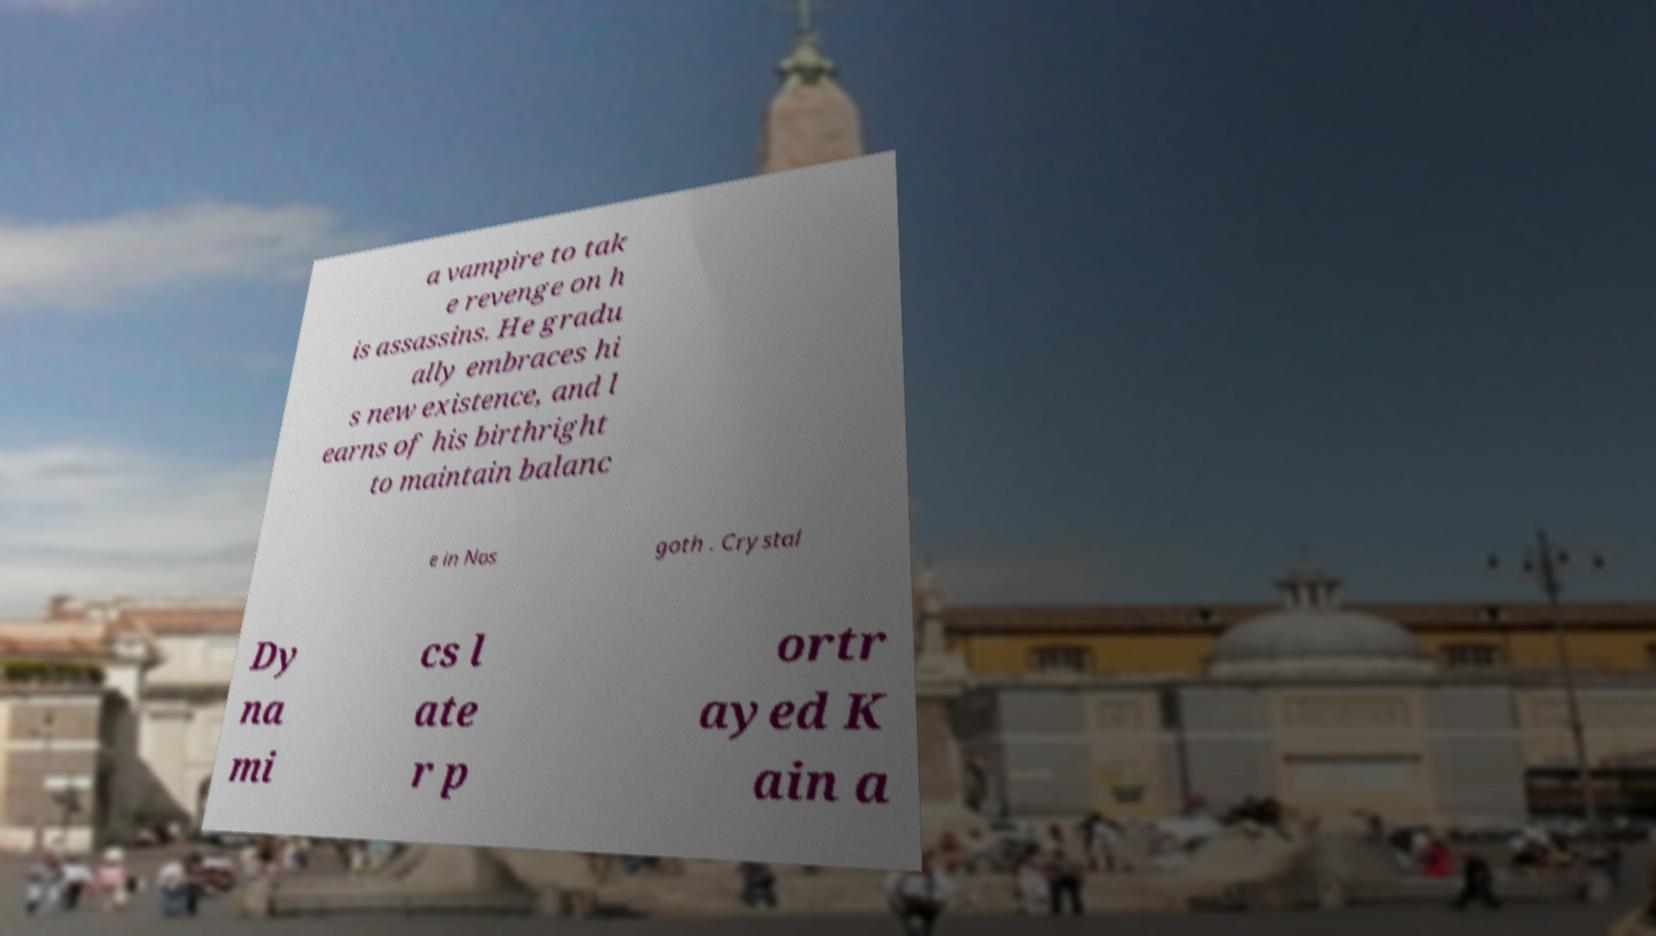Please identify and transcribe the text found in this image. a vampire to tak e revenge on h is assassins. He gradu ally embraces hi s new existence, and l earns of his birthright to maintain balanc e in Nos goth . Crystal Dy na mi cs l ate r p ortr ayed K ain a 